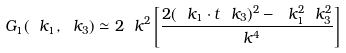Convert formula to latex. <formula><loc_0><loc_0><loc_500><loc_500>G _ { 1 } ( \ k _ { 1 } , \ k _ { 3 } ) \simeq 2 \ k ^ { 2 } \left [ \frac { 2 ( \ k _ { 1 } \cdot t \ k _ { 3 } ) ^ { 2 } - \ k _ { 1 } ^ { 2 } \ k _ { 3 } ^ { 2 } } { \ k ^ { 4 } } \right ]</formula> 